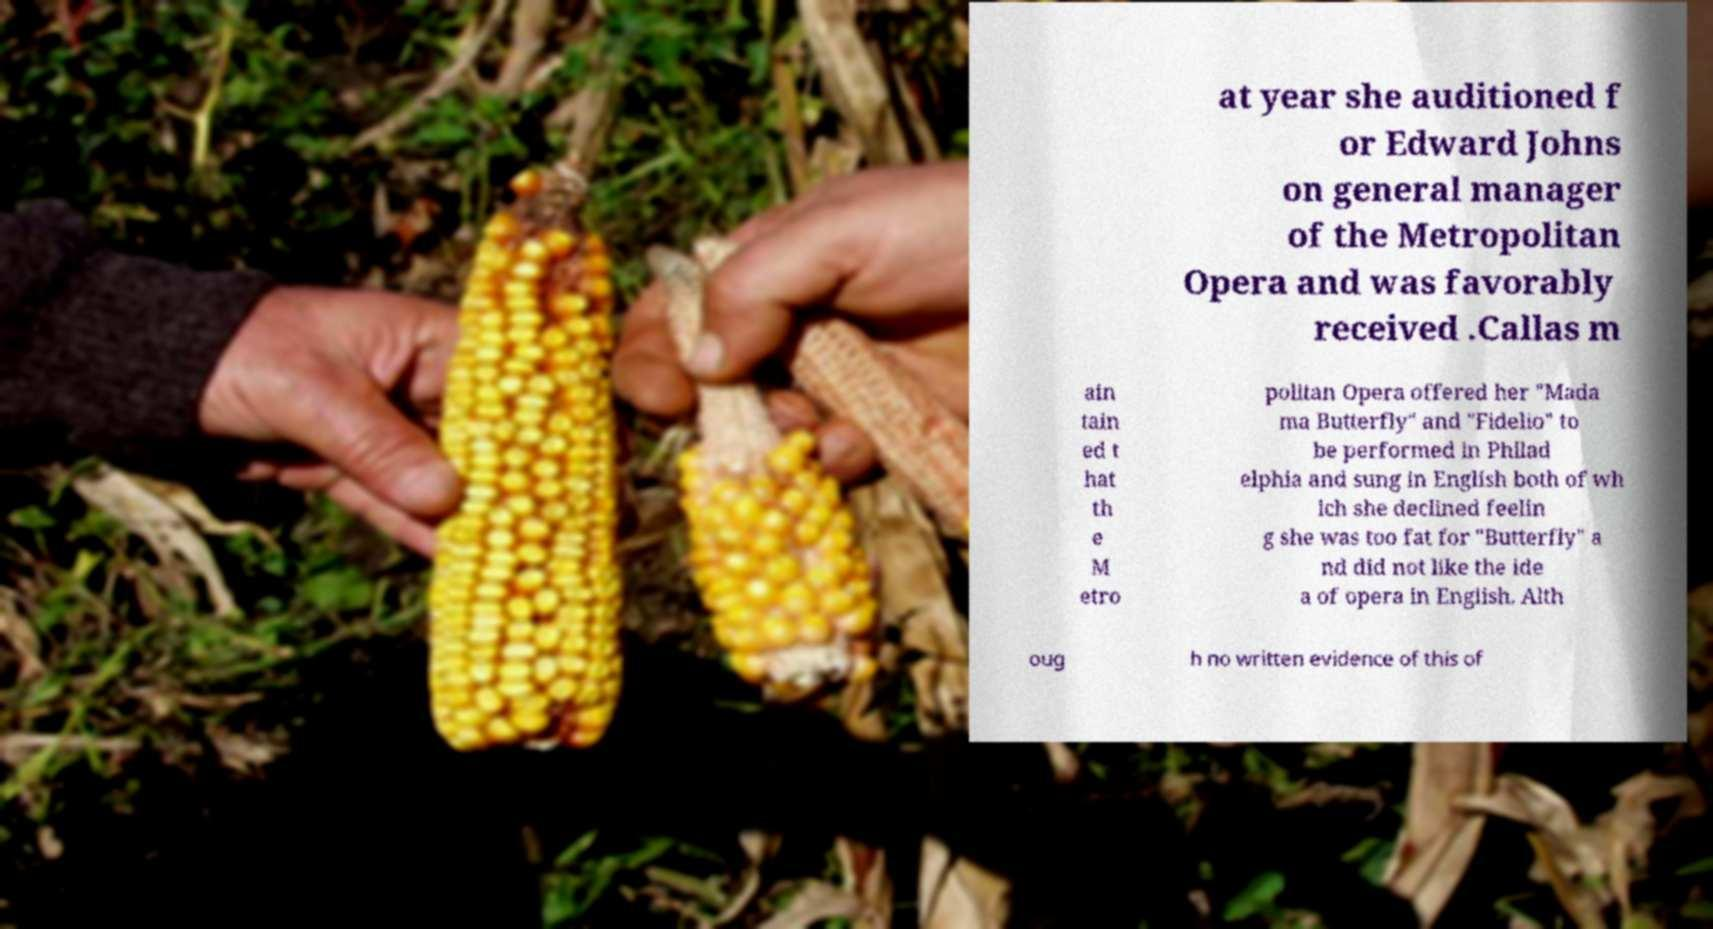I need the written content from this picture converted into text. Can you do that? at year she auditioned f or Edward Johns on general manager of the Metropolitan Opera and was favorably received .Callas m ain tain ed t hat th e M etro politan Opera offered her "Mada ma Butterfly" and "Fidelio" to be performed in Philad elphia and sung in English both of wh ich she declined feelin g she was too fat for "Butterfly" a nd did not like the ide a of opera in English. Alth oug h no written evidence of this of 